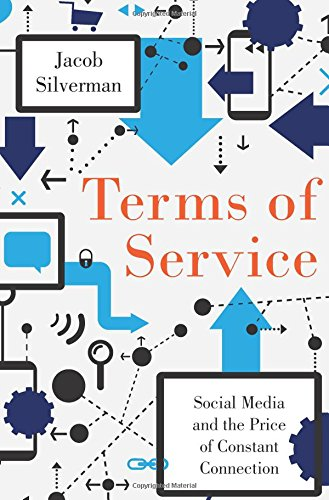What is the genre of this book? This book falls under the 'Computers & Technology' genre, focusing specifically on the impacts and implications of social media use. 